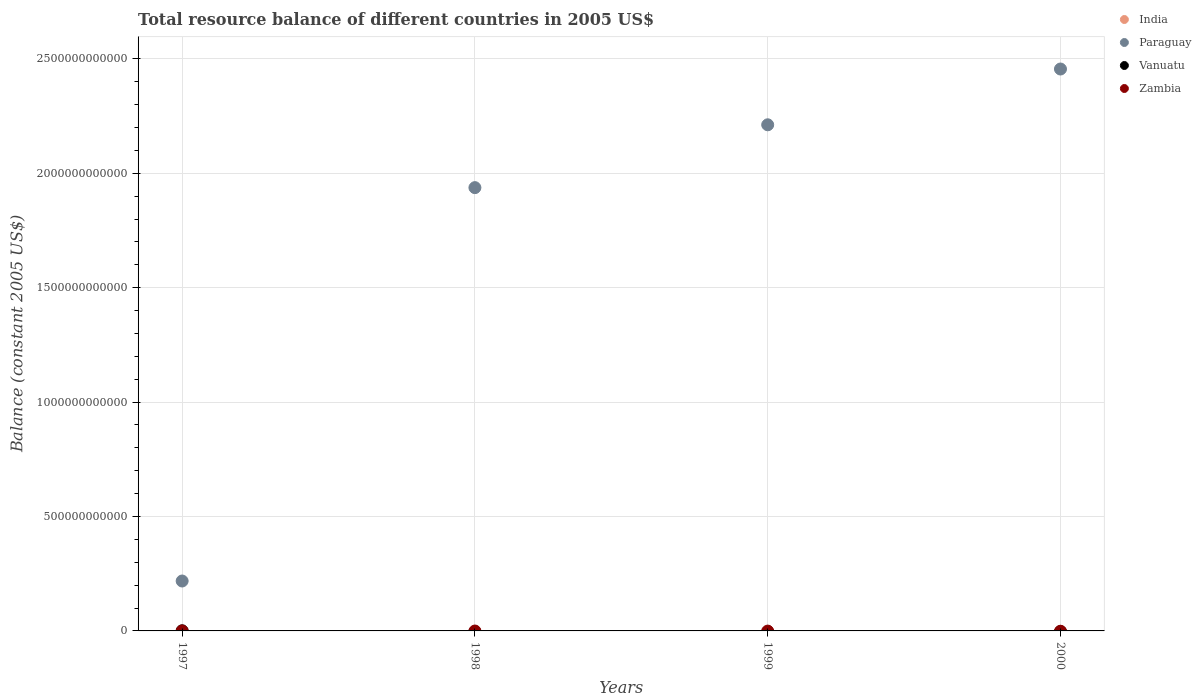What is the total resource balance in Vanuatu in 2000?
Offer a terse response. 0. Across all years, what is the maximum total resource balance in Paraguay?
Your response must be concise. 2.46e+12. What is the total total resource balance in Paraguay in the graph?
Your answer should be compact. 6.82e+12. What is the difference between the total resource balance in Paraguay in 1997 and the total resource balance in Vanuatu in 2000?
Your answer should be compact. 2.18e+11. What is the average total resource balance in Paraguay per year?
Make the answer very short. 1.71e+12. What is the ratio of the total resource balance in Paraguay in 1997 to that in 1998?
Your response must be concise. 0.11. What is the difference between the highest and the second highest total resource balance in Paraguay?
Make the answer very short. 2.44e+11. What is the difference between the highest and the lowest total resource balance in Paraguay?
Make the answer very short. 2.24e+12. In how many years, is the total resource balance in India greater than the average total resource balance in India taken over all years?
Make the answer very short. 0. Is the sum of the total resource balance in Paraguay in 1997 and 2000 greater than the maximum total resource balance in Zambia across all years?
Give a very brief answer. Yes. Is it the case that in every year, the sum of the total resource balance in Vanuatu and total resource balance in India  is greater than the sum of total resource balance in Zambia and total resource balance in Paraguay?
Make the answer very short. No. Is the total resource balance in Paraguay strictly greater than the total resource balance in Zambia over the years?
Your answer should be very brief. Yes. Is the total resource balance in India strictly less than the total resource balance in Zambia over the years?
Your response must be concise. Yes. What is the difference between two consecutive major ticks on the Y-axis?
Your answer should be compact. 5.00e+11. Are the values on the major ticks of Y-axis written in scientific E-notation?
Your answer should be very brief. No. What is the title of the graph?
Your answer should be compact. Total resource balance of different countries in 2005 US$. Does "India" appear as one of the legend labels in the graph?
Offer a very short reply. Yes. What is the label or title of the Y-axis?
Your response must be concise. Balance (constant 2005 US$). What is the Balance (constant 2005 US$) in India in 1997?
Provide a short and direct response. 0. What is the Balance (constant 2005 US$) in Paraguay in 1997?
Make the answer very short. 2.18e+11. What is the Balance (constant 2005 US$) of Vanuatu in 1997?
Ensure brevity in your answer.  5.14e+08. What is the Balance (constant 2005 US$) in Zambia in 1997?
Keep it short and to the point. 0. What is the Balance (constant 2005 US$) in Paraguay in 1998?
Provide a short and direct response. 1.94e+12. What is the Balance (constant 2005 US$) of Vanuatu in 1998?
Your answer should be compact. 0. What is the Balance (constant 2005 US$) of India in 1999?
Your answer should be compact. 0. What is the Balance (constant 2005 US$) in Paraguay in 1999?
Your response must be concise. 2.21e+12. What is the Balance (constant 2005 US$) of Vanuatu in 1999?
Your response must be concise. 0. What is the Balance (constant 2005 US$) in India in 2000?
Provide a succinct answer. 0. What is the Balance (constant 2005 US$) of Paraguay in 2000?
Make the answer very short. 2.46e+12. Across all years, what is the maximum Balance (constant 2005 US$) in Paraguay?
Your response must be concise. 2.46e+12. Across all years, what is the maximum Balance (constant 2005 US$) of Vanuatu?
Your answer should be compact. 5.14e+08. Across all years, what is the minimum Balance (constant 2005 US$) of Paraguay?
Offer a terse response. 2.18e+11. Across all years, what is the minimum Balance (constant 2005 US$) in Vanuatu?
Offer a terse response. 0. What is the total Balance (constant 2005 US$) in Paraguay in the graph?
Your answer should be very brief. 6.82e+12. What is the total Balance (constant 2005 US$) of Vanuatu in the graph?
Offer a very short reply. 5.14e+08. What is the total Balance (constant 2005 US$) of Zambia in the graph?
Your answer should be very brief. 0. What is the difference between the Balance (constant 2005 US$) of Paraguay in 1997 and that in 1998?
Keep it short and to the point. -1.72e+12. What is the difference between the Balance (constant 2005 US$) of Paraguay in 1997 and that in 1999?
Provide a succinct answer. -1.99e+12. What is the difference between the Balance (constant 2005 US$) in Paraguay in 1997 and that in 2000?
Keep it short and to the point. -2.24e+12. What is the difference between the Balance (constant 2005 US$) in Paraguay in 1998 and that in 1999?
Provide a succinct answer. -2.75e+11. What is the difference between the Balance (constant 2005 US$) of Paraguay in 1998 and that in 2000?
Your answer should be compact. -5.18e+11. What is the difference between the Balance (constant 2005 US$) of Paraguay in 1999 and that in 2000?
Offer a terse response. -2.44e+11. What is the average Balance (constant 2005 US$) in India per year?
Ensure brevity in your answer.  0. What is the average Balance (constant 2005 US$) in Paraguay per year?
Keep it short and to the point. 1.71e+12. What is the average Balance (constant 2005 US$) in Vanuatu per year?
Make the answer very short. 1.28e+08. What is the average Balance (constant 2005 US$) of Zambia per year?
Offer a very short reply. 0. In the year 1997, what is the difference between the Balance (constant 2005 US$) in Paraguay and Balance (constant 2005 US$) in Vanuatu?
Keep it short and to the point. 2.18e+11. What is the ratio of the Balance (constant 2005 US$) of Paraguay in 1997 to that in 1998?
Ensure brevity in your answer.  0.11. What is the ratio of the Balance (constant 2005 US$) in Paraguay in 1997 to that in 1999?
Provide a succinct answer. 0.1. What is the ratio of the Balance (constant 2005 US$) of Paraguay in 1997 to that in 2000?
Ensure brevity in your answer.  0.09. What is the ratio of the Balance (constant 2005 US$) in Paraguay in 1998 to that in 1999?
Your answer should be very brief. 0.88. What is the ratio of the Balance (constant 2005 US$) of Paraguay in 1998 to that in 2000?
Provide a succinct answer. 0.79. What is the ratio of the Balance (constant 2005 US$) in Paraguay in 1999 to that in 2000?
Make the answer very short. 0.9. What is the difference between the highest and the second highest Balance (constant 2005 US$) of Paraguay?
Provide a succinct answer. 2.44e+11. What is the difference between the highest and the lowest Balance (constant 2005 US$) of Paraguay?
Your answer should be very brief. 2.24e+12. What is the difference between the highest and the lowest Balance (constant 2005 US$) of Vanuatu?
Offer a very short reply. 5.14e+08. 